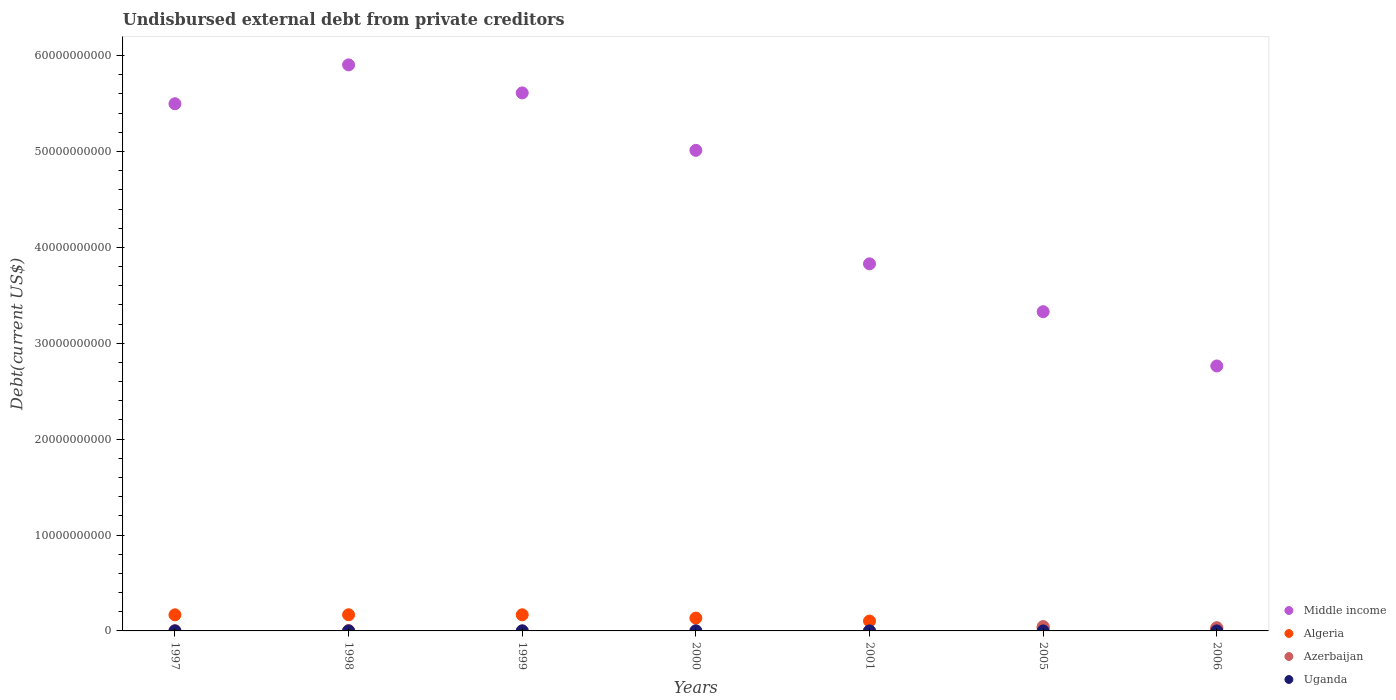How many different coloured dotlines are there?
Make the answer very short. 4. What is the total debt in Middle income in 2000?
Provide a short and direct response. 5.01e+1. Across all years, what is the maximum total debt in Algeria?
Keep it short and to the point. 1.69e+09. Across all years, what is the minimum total debt in Azerbaijan?
Your answer should be compact. 4.40e+04. What is the total total debt in Algeria in the graph?
Provide a short and direct response. 7.98e+09. What is the difference between the total debt in Middle income in 2005 and that in 2006?
Make the answer very short. 5.66e+09. What is the difference between the total debt in Azerbaijan in 2000 and the total debt in Algeria in 2005?
Ensure brevity in your answer.  -3.37e+08. What is the average total debt in Middle income per year?
Your response must be concise. 4.56e+1. In the year 1997, what is the difference between the total debt in Algeria and total debt in Middle income?
Offer a terse response. -5.33e+1. What is the ratio of the total debt in Uganda in 1998 to that in 2006?
Your answer should be compact. 6.67. Is the total debt in Middle income in 2000 less than that in 2006?
Provide a short and direct response. No. Is the difference between the total debt in Algeria in 1999 and 2000 greater than the difference between the total debt in Middle income in 1999 and 2000?
Your response must be concise. No. What is the difference between the highest and the second highest total debt in Algeria?
Offer a very short reply. 3.66e+06. What is the difference between the highest and the lowest total debt in Algeria?
Provide a short and direct response. 1.45e+09. Is it the case that in every year, the sum of the total debt in Uganda and total debt in Algeria  is greater than the total debt in Middle income?
Offer a terse response. No. Does the total debt in Algeria monotonically increase over the years?
Your answer should be very brief. No. Is the total debt in Uganda strictly greater than the total debt in Middle income over the years?
Provide a succinct answer. No. Is the total debt in Algeria strictly less than the total debt in Uganda over the years?
Offer a terse response. No. How many dotlines are there?
Offer a terse response. 4. How many years are there in the graph?
Provide a succinct answer. 7. What is the difference between two consecutive major ticks on the Y-axis?
Give a very brief answer. 1.00e+1. Does the graph contain grids?
Your response must be concise. No. Where does the legend appear in the graph?
Provide a short and direct response. Bottom right. What is the title of the graph?
Offer a very short reply. Undisbursed external debt from private creditors. Does "Senegal" appear as one of the legend labels in the graph?
Provide a succinct answer. No. What is the label or title of the Y-axis?
Offer a very short reply. Debt(current US$). What is the Debt(current US$) of Middle income in 1997?
Offer a very short reply. 5.50e+1. What is the Debt(current US$) in Algeria in 1997?
Make the answer very short. 1.68e+09. What is the Debt(current US$) of Azerbaijan in 1997?
Give a very brief answer. 2.42e+07. What is the Debt(current US$) in Uganda in 1997?
Give a very brief answer. 1.96e+05. What is the Debt(current US$) in Middle income in 1998?
Your answer should be compact. 5.90e+1. What is the Debt(current US$) of Algeria in 1998?
Provide a succinct answer. 1.69e+09. What is the Debt(current US$) in Azerbaijan in 1998?
Your answer should be very brief. 3.81e+07. What is the Debt(current US$) of Middle income in 1999?
Your answer should be very brief. 5.61e+1. What is the Debt(current US$) of Algeria in 1999?
Ensure brevity in your answer.  1.68e+09. What is the Debt(current US$) of Azerbaijan in 1999?
Offer a very short reply. 3.53e+06. What is the Debt(current US$) of Uganda in 1999?
Give a very brief answer. 1.76e+06. What is the Debt(current US$) in Middle income in 2000?
Provide a short and direct response. 5.01e+1. What is the Debt(current US$) in Algeria in 2000?
Your answer should be compact. 1.34e+09. What is the Debt(current US$) in Azerbaijan in 2000?
Ensure brevity in your answer.  5.81e+05. What is the Debt(current US$) in Uganda in 2000?
Your response must be concise. 4.61e+06. What is the Debt(current US$) of Middle income in 2001?
Your response must be concise. 3.83e+1. What is the Debt(current US$) of Algeria in 2001?
Give a very brief answer. 1.03e+09. What is the Debt(current US$) of Azerbaijan in 2001?
Make the answer very short. 4.40e+04. What is the Debt(current US$) of Uganda in 2001?
Your answer should be compact. 3.35e+05. What is the Debt(current US$) of Middle income in 2005?
Your response must be concise. 3.33e+1. What is the Debt(current US$) in Algeria in 2005?
Your answer should be very brief. 3.37e+08. What is the Debt(current US$) of Azerbaijan in 2005?
Ensure brevity in your answer.  4.53e+08. What is the Debt(current US$) of Uganda in 2005?
Offer a very short reply. 2.10e+04. What is the Debt(current US$) of Middle income in 2006?
Your answer should be compact. 2.76e+1. What is the Debt(current US$) in Algeria in 2006?
Offer a very short reply. 2.33e+08. What is the Debt(current US$) in Azerbaijan in 2006?
Keep it short and to the point. 3.36e+08. What is the Debt(current US$) of Uganda in 2006?
Offer a terse response. 2.40e+04. Across all years, what is the maximum Debt(current US$) of Middle income?
Offer a very short reply. 5.90e+1. Across all years, what is the maximum Debt(current US$) in Algeria?
Give a very brief answer. 1.69e+09. Across all years, what is the maximum Debt(current US$) of Azerbaijan?
Give a very brief answer. 4.53e+08. Across all years, what is the maximum Debt(current US$) in Uganda?
Provide a short and direct response. 4.61e+06. Across all years, what is the minimum Debt(current US$) in Middle income?
Keep it short and to the point. 2.76e+1. Across all years, what is the minimum Debt(current US$) in Algeria?
Make the answer very short. 2.33e+08. Across all years, what is the minimum Debt(current US$) of Azerbaijan?
Provide a short and direct response. 4.40e+04. Across all years, what is the minimum Debt(current US$) of Uganda?
Offer a very short reply. 2.10e+04. What is the total Debt(current US$) of Middle income in the graph?
Offer a terse response. 3.19e+11. What is the total Debt(current US$) of Algeria in the graph?
Your answer should be very brief. 7.98e+09. What is the total Debt(current US$) in Azerbaijan in the graph?
Your answer should be compact. 8.55e+08. What is the total Debt(current US$) in Uganda in the graph?
Your answer should be very brief. 7.11e+06. What is the difference between the Debt(current US$) in Middle income in 1997 and that in 1998?
Provide a short and direct response. -4.05e+09. What is the difference between the Debt(current US$) of Algeria in 1997 and that in 1998?
Offer a very short reply. -7.31e+06. What is the difference between the Debt(current US$) in Azerbaijan in 1997 and that in 1998?
Your response must be concise. -1.40e+07. What is the difference between the Debt(current US$) of Uganda in 1997 and that in 1998?
Ensure brevity in your answer.  3.60e+04. What is the difference between the Debt(current US$) in Middle income in 1997 and that in 1999?
Your response must be concise. -1.13e+09. What is the difference between the Debt(current US$) in Algeria in 1997 and that in 1999?
Provide a short and direct response. -3.65e+06. What is the difference between the Debt(current US$) in Azerbaijan in 1997 and that in 1999?
Give a very brief answer. 2.06e+07. What is the difference between the Debt(current US$) of Uganda in 1997 and that in 1999?
Give a very brief answer. -1.57e+06. What is the difference between the Debt(current US$) in Middle income in 1997 and that in 2000?
Your answer should be very brief. 4.86e+09. What is the difference between the Debt(current US$) of Algeria in 1997 and that in 2000?
Offer a very short reply. 3.40e+08. What is the difference between the Debt(current US$) of Azerbaijan in 1997 and that in 2000?
Give a very brief answer. 2.36e+07. What is the difference between the Debt(current US$) in Uganda in 1997 and that in 2000?
Make the answer very short. -4.42e+06. What is the difference between the Debt(current US$) in Middle income in 1997 and that in 2001?
Give a very brief answer. 1.67e+1. What is the difference between the Debt(current US$) of Algeria in 1997 and that in 2001?
Your answer should be compact. 6.52e+08. What is the difference between the Debt(current US$) of Azerbaijan in 1997 and that in 2001?
Your answer should be compact. 2.41e+07. What is the difference between the Debt(current US$) in Uganda in 1997 and that in 2001?
Your answer should be very brief. -1.39e+05. What is the difference between the Debt(current US$) in Middle income in 1997 and that in 2005?
Your answer should be compact. 2.17e+1. What is the difference between the Debt(current US$) in Algeria in 1997 and that in 2005?
Give a very brief answer. 1.34e+09. What is the difference between the Debt(current US$) of Azerbaijan in 1997 and that in 2005?
Your response must be concise. -4.29e+08. What is the difference between the Debt(current US$) of Uganda in 1997 and that in 2005?
Keep it short and to the point. 1.75e+05. What is the difference between the Debt(current US$) in Middle income in 1997 and that in 2006?
Your answer should be very brief. 2.73e+1. What is the difference between the Debt(current US$) in Algeria in 1997 and that in 2006?
Make the answer very short. 1.45e+09. What is the difference between the Debt(current US$) of Azerbaijan in 1997 and that in 2006?
Offer a terse response. -3.12e+08. What is the difference between the Debt(current US$) in Uganda in 1997 and that in 2006?
Make the answer very short. 1.72e+05. What is the difference between the Debt(current US$) of Middle income in 1998 and that in 1999?
Your answer should be compact. 2.92e+09. What is the difference between the Debt(current US$) in Algeria in 1998 and that in 1999?
Your answer should be compact. 3.66e+06. What is the difference between the Debt(current US$) in Azerbaijan in 1998 and that in 1999?
Your response must be concise. 3.46e+07. What is the difference between the Debt(current US$) of Uganda in 1998 and that in 1999?
Offer a very short reply. -1.60e+06. What is the difference between the Debt(current US$) of Middle income in 1998 and that in 2000?
Give a very brief answer. 8.91e+09. What is the difference between the Debt(current US$) in Algeria in 1998 and that in 2000?
Keep it short and to the point. 3.47e+08. What is the difference between the Debt(current US$) in Azerbaijan in 1998 and that in 2000?
Offer a terse response. 3.76e+07. What is the difference between the Debt(current US$) in Uganda in 1998 and that in 2000?
Your response must be concise. -4.45e+06. What is the difference between the Debt(current US$) of Middle income in 1998 and that in 2001?
Keep it short and to the point. 2.07e+1. What is the difference between the Debt(current US$) in Algeria in 1998 and that in 2001?
Keep it short and to the point. 6.59e+08. What is the difference between the Debt(current US$) of Azerbaijan in 1998 and that in 2001?
Your response must be concise. 3.81e+07. What is the difference between the Debt(current US$) of Uganda in 1998 and that in 2001?
Your answer should be compact. -1.75e+05. What is the difference between the Debt(current US$) of Middle income in 1998 and that in 2005?
Your answer should be very brief. 2.57e+1. What is the difference between the Debt(current US$) in Algeria in 1998 and that in 2005?
Your answer should be compact. 1.35e+09. What is the difference between the Debt(current US$) in Azerbaijan in 1998 and that in 2005?
Ensure brevity in your answer.  -4.15e+08. What is the difference between the Debt(current US$) of Uganda in 1998 and that in 2005?
Offer a very short reply. 1.39e+05. What is the difference between the Debt(current US$) in Middle income in 1998 and that in 2006?
Make the answer very short. 3.14e+1. What is the difference between the Debt(current US$) in Algeria in 1998 and that in 2006?
Make the answer very short. 1.45e+09. What is the difference between the Debt(current US$) of Azerbaijan in 1998 and that in 2006?
Offer a very short reply. -2.98e+08. What is the difference between the Debt(current US$) of Uganda in 1998 and that in 2006?
Offer a very short reply. 1.36e+05. What is the difference between the Debt(current US$) in Middle income in 1999 and that in 2000?
Provide a short and direct response. 5.99e+09. What is the difference between the Debt(current US$) of Algeria in 1999 and that in 2000?
Make the answer very short. 3.43e+08. What is the difference between the Debt(current US$) in Azerbaijan in 1999 and that in 2000?
Your answer should be very brief. 2.95e+06. What is the difference between the Debt(current US$) of Uganda in 1999 and that in 2000?
Give a very brief answer. -2.85e+06. What is the difference between the Debt(current US$) of Middle income in 1999 and that in 2001?
Keep it short and to the point. 1.78e+1. What is the difference between the Debt(current US$) of Algeria in 1999 and that in 2001?
Make the answer very short. 6.55e+08. What is the difference between the Debt(current US$) in Azerbaijan in 1999 and that in 2001?
Provide a succinct answer. 3.49e+06. What is the difference between the Debt(current US$) in Uganda in 1999 and that in 2001?
Provide a succinct answer. 1.43e+06. What is the difference between the Debt(current US$) in Middle income in 1999 and that in 2005?
Offer a terse response. 2.28e+1. What is the difference between the Debt(current US$) in Algeria in 1999 and that in 2005?
Ensure brevity in your answer.  1.34e+09. What is the difference between the Debt(current US$) of Azerbaijan in 1999 and that in 2005?
Your answer should be compact. -4.49e+08. What is the difference between the Debt(current US$) in Uganda in 1999 and that in 2005?
Offer a terse response. 1.74e+06. What is the difference between the Debt(current US$) in Middle income in 1999 and that in 2006?
Ensure brevity in your answer.  2.85e+1. What is the difference between the Debt(current US$) of Algeria in 1999 and that in 2006?
Provide a short and direct response. 1.45e+09. What is the difference between the Debt(current US$) of Azerbaijan in 1999 and that in 2006?
Provide a short and direct response. -3.33e+08. What is the difference between the Debt(current US$) of Uganda in 1999 and that in 2006?
Ensure brevity in your answer.  1.74e+06. What is the difference between the Debt(current US$) in Middle income in 2000 and that in 2001?
Ensure brevity in your answer.  1.18e+1. What is the difference between the Debt(current US$) of Algeria in 2000 and that in 2001?
Your answer should be very brief. 3.12e+08. What is the difference between the Debt(current US$) in Azerbaijan in 2000 and that in 2001?
Offer a terse response. 5.37e+05. What is the difference between the Debt(current US$) of Uganda in 2000 and that in 2001?
Provide a succinct answer. 4.28e+06. What is the difference between the Debt(current US$) of Middle income in 2000 and that in 2005?
Provide a succinct answer. 1.68e+1. What is the difference between the Debt(current US$) in Algeria in 2000 and that in 2005?
Provide a short and direct response. 1.00e+09. What is the difference between the Debt(current US$) in Azerbaijan in 2000 and that in 2005?
Provide a succinct answer. -4.52e+08. What is the difference between the Debt(current US$) in Uganda in 2000 and that in 2005?
Keep it short and to the point. 4.59e+06. What is the difference between the Debt(current US$) of Middle income in 2000 and that in 2006?
Keep it short and to the point. 2.25e+1. What is the difference between the Debt(current US$) in Algeria in 2000 and that in 2006?
Ensure brevity in your answer.  1.11e+09. What is the difference between the Debt(current US$) of Azerbaijan in 2000 and that in 2006?
Your answer should be compact. -3.36e+08. What is the difference between the Debt(current US$) in Uganda in 2000 and that in 2006?
Your answer should be very brief. 4.59e+06. What is the difference between the Debt(current US$) of Middle income in 2001 and that in 2005?
Offer a very short reply. 4.99e+09. What is the difference between the Debt(current US$) of Algeria in 2001 and that in 2005?
Make the answer very short. 6.89e+08. What is the difference between the Debt(current US$) in Azerbaijan in 2001 and that in 2005?
Provide a succinct answer. -4.53e+08. What is the difference between the Debt(current US$) of Uganda in 2001 and that in 2005?
Your answer should be compact. 3.14e+05. What is the difference between the Debt(current US$) in Middle income in 2001 and that in 2006?
Offer a very short reply. 1.07e+1. What is the difference between the Debt(current US$) in Algeria in 2001 and that in 2006?
Give a very brief answer. 7.93e+08. What is the difference between the Debt(current US$) of Azerbaijan in 2001 and that in 2006?
Your answer should be compact. -3.36e+08. What is the difference between the Debt(current US$) in Uganda in 2001 and that in 2006?
Keep it short and to the point. 3.11e+05. What is the difference between the Debt(current US$) in Middle income in 2005 and that in 2006?
Give a very brief answer. 5.66e+09. What is the difference between the Debt(current US$) of Algeria in 2005 and that in 2006?
Make the answer very short. 1.04e+08. What is the difference between the Debt(current US$) of Azerbaijan in 2005 and that in 2006?
Ensure brevity in your answer.  1.17e+08. What is the difference between the Debt(current US$) in Uganda in 2005 and that in 2006?
Your answer should be compact. -3000. What is the difference between the Debt(current US$) of Middle income in 1997 and the Debt(current US$) of Algeria in 1998?
Make the answer very short. 5.33e+1. What is the difference between the Debt(current US$) of Middle income in 1997 and the Debt(current US$) of Azerbaijan in 1998?
Your answer should be compact. 5.49e+1. What is the difference between the Debt(current US$) of Middle income in 1997 and the Debt(current US$) of Uganda in 1998?
Offer a terse response. 5.50e+1. What is the difference between the Debt(current US$) of Algeria in 1997 and the Debt(current US$) of Azerbaijan in 1998?
Your response must be concise. 1.64e+09. What is the difference between the Debt(current US$) in Algeria in 1997 and the Debt(current US$) in Uganda in 1998?
Provide a short and direct response. 1.68e+09. What is the difference between the Debt(current US$) in Azerbaijan in 1997 and the Debt(current US$) in Uganda in 1998?
Keep it short and to the point. 2.40e+07. What is the difference between the Debt(current US$) in Middle income in 1997 and the Debt(current US$) in Algeria in 1999?
Offer a terse response. 5.33e+1. What is the difference between the Debt(current US$) of Middle income in 1997 and the Debt(current US$) of Azerbaijan in 1999?
Keep it short and to the point. 5.50e+1. What is the difference between the Debt(current US$) in Middle income in 1997 and the Debt(current US$) in Uganda in 1999?
Ensure brevity in your answer.  5.50e+1. What is the difference between the Debt(current US$) in Algeria in 1997 and the Debt(current US$) in Azerbaijan in 1999?
Your answer should be compact. 1.67e+09. What is the difference between the Debt(current US$) in Algeria in 1997 and the Debt(current US$) in Uganda in 1999?
Provide a short and direct response. 1.68e+09. What is the difference between the Debt(current US$) in Azerbaijan in 1997 and the Debt(current US$) in Uganda in 1999?
Your answer should be compact. 2.24e+07. What is the difference between the Debt(current US$) in Middle income in 1997 and the Debt(current US$) in Algeria in 2000?
Keep it short and to the point. 5.36e+1. What is the difference between the Debt(current US$) in Middle income in 1997 and the Debt(current US$) in Azerbaijan in 2000?
Your answer should be compact. 5.50e+1. What is the difference between the Debt(current US$) in Middle income in 1997 and the Debt(current US$) in Uganda in 2000?
Your answer should be compact. 5.50e+1. What is the difference between the Debt(current US$) in Algeria in 1997 and the Debt(current US$) in Azerbaijan in 2000?
Your answer should be very brief. 1.68e+09. What is the difference between the Debt(current US$) in Algeria in 1997 and the Debt(current US$) in Uganda in 2000?
Offer a terse response. 1.67e+09. What is the difference between the Debt(current US$) of Azerbaijan in 1997 and the Debt(current US$) of Uganda in 2000?
Your answer should be compact. 1.96e+07. What is the difference between the Debt(current US$) in Middle income in 1997 and the Debt(current US$) in Algeria in 2001?
Provide a short and direct response. 5.40e+1. What is the difference between the Debt(current US$) of Middle income in 1997 and the Debt(current US$) of Azerbaijan in 2001?
Ensure brevity in your answer.  5.50e+1. What is the difference between the Debt(current US$) of Middle income in 1997 and the Debt(current US$) of Uganda in 2001?
Offer a terse response. 5.50e+1. What is the difference between the Debt(current US$) in Algeria in 1997 and the Debt(current US$) in Azerbaijan in 2001?
Make the answer very short. 1.68e+09. What is the difference between the Debt(current US$) in Algeria in 1997 and the Debt(current US$) in Uganda in 2001?
Your answer should be compact. 1.68e+09. What is the difference between the Debt(current US$) in Azerbaijan in 1997 and the Debt(current US$) in Uganda in 2001?
Your answer should be very brief. 2.38e+07. What is the difference between the Debt(current US$) in Middle income in 1997 and the Debt(current US$) in Algeria in 2005?
Your answer should be compact. 5.46e+1. What is the difference between the Debt(current US$) in Middle income in 1997 and the Debt(current US$) in Azerbaijan in 2005?
Provide a succinct answer. 5.45e+1. What is the difference between the Debt(current US$) of Middle income in 1997 and the Debt(current US$) of Uganda in 2005?
Provide a succinct answer. 5.50e+1. What is the difference between the Debt(current US$) in Algeria in 1997 and the Debt(current US$) in Azerbaijan in 2005?
Your response must be concise. 1.23e+09. What is the difference between the Debt(current US$) of Algeria in 1997 and the Debt(current US$) of Uganda in 2005?
Provide a short and direct response. 1.68e+09. What is the difference between the Debt(current US$) in Azerbaijan in 1997 and the Debt(current US$) in Uganda in 2005?
Provide a short and direct response. 2.42e+07. What is the difference between the Debt(current US$) in Middle income in 1997 and the Debt(current US$) in Algeria in 2006?
Ensure brevity in your answer.  5.47e+1. What is the difference between the Debt(current US$) in Middle income in 1997 and the Debt(current US$) in Azerbaijan in 2006?
Provide a succinct answer. 5.46e+1. What is the difference between the Debt(current US$) of Middle income in 1997 and the Debt(current US$) of Uganda in 2006?
Offer a very short reply. 5.50e+1. What is the difference between the Debt(current US$) in Algeria in 1997 and the Debt(current US$) in Azerbaijan in 2006?
Make the answer very short. 1.34e+09. What is the difference between the Debt(current US$) of Algeria in 1997 and the Debt(current US$) of Uganda in 2006?
Offer a terse response. 1.68e+09. What is the difference between the Debt(current US$) in Azerbaijan in 1997 and the Debt(current US$) in Uganda in 2006?
Make the answer very short. 2.41e+07. What is the difference between the Debt(current US$) of Middle income in 1998 and the Debt(current US$) of Algeria in 1999?
Your answer should be compact. 5.73e+1. What is the difference between the Debt(current US$) of Middle income in 1998 and the Debt(current US$) of Azerbaijan in 1999?
Offer a terse response. 5.90e+1. What is the difference between the Debt(current US$) in Middle income in 1998 and the Debt(current US$) in Uganda in 1999?
Offer a terse response. 5.90e+1. What is the difference between the Debt(current US$) in Algeria in 1998 and the Debt(current US$) in Azerbaijan in 1999?
Provide a succinct answer. 1.68e+09. What is the difference between the Debt(current US$) of Algeria in 1998 and the Debt(current US$) of Uganda in 1999?
Provide a short and direct response. 1.68e+09. What is the difference between the Debt(current US$) of Azerbaijan in 1998 and the Debt(current US$) of Uganda in 1999?
Keep it short and to the point. 3.64e+07. What is the difference between the Debt(current US$) of Middle income in 1998 and the Debt(current US$) of Algeria in 2000?
Ensure brevity in your answer.  5.77e+1. What is the difference between the Debt(current US$) in Middle income in 1998 and the Debt(current US$) in Azerbaijan in 2000?
Give a very brief answer. 5.90e+1. What is the difference between the Debt(current US$) of Middle income in 1998 and the Debt(current US$) of Uganda in 2000?
Make the answer very short. 5.90e+1. What is the difference between the Debt(current US$) of Algeria in 1998 and the Debt(current US$) of Azerbaijan in 2000?
Provide a succinct answer. 1.69e+09. What is the difference between the Debt(current US$) in Algeria in 1998 and the Debt(current US$) in Uganda in 2000?
Offer a very short reply. 1.68e+09. What is the difference between the Debt(current US$) of Azerbaijan in 1998 and the Debt(current US$) of Uganda in 2000?
Ensure brevity in your answer.  3.35e+07. What is the difference between the Debt(current US$) in Middle income in 1998 and the Debt(current US$) in Algeria in 2001?
Keep it short and to the point. 5.80e+1. What is the difference between the Debt(current US$) in Middle income in 1998 and the Debt(current US$) in Azerbaijan in 2001?
Ensure brevity in your answer.  5.90e+1. What is the difference between the Debt(current US$) in Middle income in 1998 and the Debt(current US$) in Uganda in 2001?
Ensure brevity in your answer.  5.90e+1. What is the difference between the Debt(current US$) in Algeria in 1998 and the Debt(current US$) in Azerbaijan in 2001?
Offer a terse response. 1.69e+09. What is the difference between the Debt(current US$) of Algeria in 1998 and the Debt(current US$) of Uganda in 2001?
Give a very brief answer. 1.69e+09. What is the difference between the Debt(current US$) of Azerbaijan in 1998 and the Debt(current US$) of Uganda in 2001?
Ensure brevity in your answer.  3.78e+07. What is the difference between the Debt(current US$) in Middle income in 1998 and the Debt(current US$) in Algeria in 2005?
Your response must be concise. 5.87e+1. What is the difference between the Debt(current US$) in Middle income in 1998 and the Debt(current US$) in Azerbaijan in 2005?
Offer a very short reply. 5.86e+1. What is the difference between the Debt(current US$) of Middle income in 1998 and the Debt(current US$) of Uganda in 2005?
Offer a very short reply. 5.90e+1. What is the difference between the Debt(current US$) of Algeria in 1998 and the Debt(current US$) of Azerbaijan in 2005?
Keep it short and to the point. 1.23e+09. What is the difference between the Debt(current US$) of Algeria in 1998 and the Debt(current US$) of Uganda in 2005?
Provide a short and direct response. 1.69e+09. What is the difference between the Debt(current US$) in Azerbaijan in 1998 and the Debt(current US$) in Uganda in 2005?
Your response must be concise. 3.81e+07. What is the difference between the Debt(current US$) in Middle income in 1998 and the Debt(current US$) in Algeria in 2006?
Keep it short and to the point. 5.88e+1. What is the difference between the Debt(current US$) in Middle income in 1998 and the Debt(current US$) in Azerbaijan in 2006?
Your answer should be compact. 5.87e+1. What is the difference between the Debt(current US$) of Middle income in 1998 and the Debt(current US$) of Uganda in 2006?
Ensure brevity in your answer.  5.90e+1. What is the difference between the Debt(current US$) in Algeria in 1998 and the Debt(current US$) in Azerbaijan in 2006?
Ensure brevity in your answer.  1.35e+09. What is the difference between the Debt(current US$) of Algeria in 1998 and the Debt(current US$) of Uganda in 2006?
Your answer should be compact. 1.69e+09. What is the difference between the Debt(current US$) in Azerbaijan in 1998 and the Debt(current US$) in Uganda in 2006?
Ensure brevity in your answer.  3.81e+07. What is the difference between the Debt(current US$) of Middle income in 1999 and the Debt(current US$) of Algeria in 2000?
Offer a terse response. 5.48e+1. What is the difference between the Debt(current US$) in Middle income in 1999 and the Debt(current US$) in Azerbaijan in 2000?
Provide a succinct answer. 5.61e+1. What is the difference between the Debt(current US$) in Middle income in 1999 and the Debt(current US$) in Uganda in 2000?
Keep it short and to the point. 5.61e+1. What is the difference between the Debt(current US$) of Algeria in 1999 and the Debt(current US$) of Azerbaijan in 2000?
Offer a terse response. 1.68e+09. What is the difference between the Debt(current US$) in Algeria in 1999 and the Debt(current US$) in Uganda in 2000?
Keep it short and to the point. 1.68e+09. What is the difference between the Debt(current US$) of Azerbaijan in 1999 and the Debt(current US$) of Uganda in 2000?
Provide a succinct answer. -1.08e+06. What is the difference between the Debt(current US$) of Middle income in 1999 and the Debt(current US$) of Algeria in 2001?
Ensure brevity in your answer.  5.51e+1. What is the difference between the Debt(current US$) in Middle income in 1999 and the Debt(current US$) in Azerbaijan in 2001?
Provide a succinct answer. 5.61e+1. What is the difference between the Debt(current US$) in Middle income in 1999 and the Debt(current US$) in Uganda in 2001?
Offer a very short reply. 5.61e+1. What is the difference between the Debt(current US$) in Algeria in 1999 and the Debt(current US$) in Azerbaijan in 2001?
Ensure brevity in your answer.  1.68e+09. What is the difference between the Debt(current US$) of Algeria in 1999 and the Debt(current US$) of Uganda in 2001?
Make the answer very short. 1.68e+09. What is the difference between the Debt(current US$) of Azerbaijan in 1999 and the Debt(current US$) of Uganda in 2001?
Give a very brief answer. 3.20e+06. What is the difference between the Debt(current US$) of Middle income in 1999 and the Debt(current US$) of Algeria in 2005?
Your response must be concise. 5.58e+1. What is the difference between the Debt(current US$) in Middle income in 1999 and the Debt(current US$) in Azerbaijan in 2005?
Keep it short and to the point. 5.57e+1. What is the difference between the Debt(current US$) in Middle income in 1999 and the Debt(current US$) in Uganda in 2005?
Keep it short and to the point. 5.61e+1. What is the difference between the Debt(current US$) in Algeria in 1999 and the Debt(current US$) in Azerbaijan in 2005?
Give a very brief answer. 1.23e+09. What is the difference between the Debt(current US$) of Algeria in 1999 and the Debt(current US$) of Uganda in 2005?
Your response must be concise. 1.68e+09. What is the difference between the Debt(current US$) of Azerbaijan in 1999 and the Debt(current US$) of Uganda in 2005?
Provide a short and direct response. 3.51e+06. What is the difference between the Debt(current US$) of Middle income in 1999 and the Debt(current US$) of Algeria in 2006?
Your answer should be very brief. 5.59e+1. What is the difference between the Debt(current US$) in Middle income in 1999 and the Debt(current US$) in Azerbaijan in 2006?
Offer a very short reply. 5.58e+1. What is the difference between the Debt(current US$) of Middle income in 1999 and the Debt(current US$) of Uganda in 2006?
Your answer should be very brief. 5.61e+1. What is the difference between the Debt(current US$) of Algeria in 1999 and the Debt(current US$) of Azerbaijan in 2006?
Your response must be concise. 1.35e+09. What is the difference between the Debt(current US$) in Algeria in 1999 and the Debt(current US$) in Uganda in 2006?
Your answer should be very brief. 1.68e+09. What is the difference between the Debt(current US$) of Azerbaijan in 1999 and the Debt(current US$) of Uganda in 2006?
Ensure brevity in your answer.  3.51e+06. What is the difference between the Debt(current US$) in Middle income in 2000 and the Debt(current US$) in Algeria in 2001?
Offer a terse response. 4.91e+1. What is the difference between the Debt(current US$) in Middle income in 2000 and the Debt(current US$) in Azerbaijan in 2001?
Your response must be concise. 5.01e+1. What is the difference between the Debt(current US$) of Middle income in 2000 and the Debt(current US$) of Uganda in 2001?
Keep it short and to the point. 5.01e+1. What is the difference between the Debt(current US$) in Algeria in 2000 and the Debt(current US$) in Azerbaijan in 2001?
Provide a succinct answer. 1.34e+09. What is the difference between the Debt(current US$) of Algeria in 2000 and the Debt(current US$) of Uganda in 2001?
Provide a succinct answer. 1.34e+09. What is the difference between the Debt(current US$) of Azerbaijan in 2000 and the Debt(current US$) of Uganda in 2001?
Give a very brief answer. 2.46e+05. What is the difference between the Debt(current US$) of Middle income in 2000 and the Debt(current US$) of Algeria in 2005?
Your answer should be compact. 4.98e+1. What is the difference between the Debt(current US$) in Middle income in 2000 and the Debt(current US$) in Azerbaijan in 2005?
Keep it short and to the point. 4.97e+1. What is the difference between the Debt(current US$) of Middle income in 2000 and the Debt(current US$) of Uganda in 2005?
Make the answer very short. 5.01e+1. What is the difference between the Debt(current US$) in Algeria in 2000 and the Debt(current US$) in Azerbaijan in 2005?
Keep it short and to the point. 8.86e+08. What is the difference between the Debt(current US$) of Algeria in 2000 and the Debt(current US$) of Uganda in 2005?
Provide a short and direct response. 1.34e+09. What is the difference between the Debt(current US$) of Azerbaijan in 2000 and the Debt(current US$) of Uganda in 2005?
Ensure brevity in your answer.  5.60e+05. What is the difference between the Debt(current US$) of Middle income in 2000 and the Debt(current US$) of Algeria in 2006?
Give a very brief answer. 4.99e+1. What is the difference between the Debt(current US$) in Middle income in 2000 and the Debt(current US$) in Azerbaijan in 2006?
Make the answer very short. 4.98e+1. What is the difference between the Debt(current US$) of Middle income in 2000 and the Debt(current US$) of Uganda in 2006?
Your answer should be very brief. 5.01e+1. What is the difference between the Debt(current US$) in Algeria in 2000 and the Debt(current US$) in Azerbaijan in 2006?
Make the answer very short. 1.00e+09. What is the difference between the Debt(current US$) in Algeria in 2000 and the Debt(current US$) in Uganda in 2006?
Your response must be concise. 1.34e+09. What is the difference between the Debt(current US$) in Azerbaijan in 2000 and the Debt(current US$) in Uganda in 2006?
Keep it short and to the point. 5.57e+05. What is the difference between the Debt(current US$) of Middle income in 2001 and the Debt(current US$) of Algeria in 2005?
Your answer should be compact. 3.79e+1. What is the difference between the Debt(current US$) in Middle income in 2001 and the Debt(current US$) in Azerbaijan in 2005?
Offer a very short reply. 3.78e+1. What is the difference between the Debt(current US$) in Middle income in 2001 and the Debt(current US$) in Uganda in 2005?
Make the answer very short. 3.83e+1. What is the difference between the Debt(current US$) of Algeria in 2001 and the Debt(current US$) of Azerbaijan in 2005?
Your answer should be compact. 5.74e+08. What is the difference between the Debt(current US$) of Algeria in 2001 and the Debt(current US$) of Uganda in 2005?
Give a very brief answer. 1.03e+09. What is the difference between the Debt(current US$) in Azerbaijan in 2001 and the Debt(current US$) in Uganda in 2005?
Your response must be concise. 2.30e+04. What is the difference between the Debt(current US$) in Middle income in 2001 and the Debt(current US$) in Algeria in 2006?
Keep it short and to the point. 3.80e+1. What is the difference between the Debt(current US$) in Middle income in 2001 and the Debt(current US$) in Azerbaijan in 2006?
Ensure brevity in your answer.  3.79e+1. What is the difference between the Debt(current US$) of Middle income in 2001 and the Debt(current US$) of Uganda in 2006?
Your answer should be very brief. 3.83e+1. What is the difference between the Debt(current US$) in Algeria in 2001 and the Debt(current US$) in Azerbaijan in 2006?
Keep it short and to the point. 6.91e+08. What is the difference between the Debt(current US$) in Algeria in 2001 and the Debt(current US$) in Uganda in 2006?
Ensure brevity in your answer.  1.03e+09. What is the difference between the Debt(current US$) in Middle income in 2005 and the Debt(current US$) in Algeria in 2006?
Offer a terse response. 3.31e+1. What is the difference between the Debt(current US$) in Middle income in 2005 and the Debt(current US$) in Azerbaijan in 2006?
Give a very brief answer. 3.30e+1. What is the difference between the Debt(current US$) of Middle income in 2005 and the Debt(current US$) of Uganda in 2006?
Provide a short and direct response. 3.33e+1. What is the difference between the Debt(current US$) of Algeria in 2005 and the Debt(current US$) of Azerbaijan in 2006?
Offer a very short reply. 1.30e+06. What is the difference between the Debt(current US$) of Algeria in 2005 and the Debt(current US$) of Uganda in 2006?
Offer a terse response. 3.37e+08. What is the difference between the Debt(current US$) in Azerbaijan in 2005 and the Debt(current US$) in Uganda in 2006?
Provide a short and direct response. 4.53e+08. What is the average Debt(current US$) in Middle income per year?
Offer a very short reply. 4.56e+1. What is the average Debt(current US$) in Algeria per year?
Provide a short and direct response. 1.14e+09. What is the average Debt(current US$) in Azerbaijan per year?
Provide a short and direct response. 1.22e+08. What is the average Debt(current US$) in Uganda per year?
Your response must be concise. 1.02e+06. In the year 1997, what is the difference between the Debt(current US$) in Middle income and Debt(current US$) in Algeria?
Give a very brief answer. 5.33e+1. In the year 1997, what is the difference between the Debt(current US$) of Middle income and Debt(current US$) of Azerbaijan?
Make the answer very short. 5.50e+1. In the year 1997, what is the difference between the Debt(current US$) of Middle income and Debt(current US$) of Uganda?
Provide a short and direct response. 5.50e+1. In the year 1997, what is the difference between the Debt(current US$) of Algeria and Debt(current US$) of Azerbaijan?
Your answer should be very brief. 1.65e+09. In the year 1997, what is the difference between the Debt(current US$) of Algeria and Debt(current US$) of Uganda?
Make the answer very short. 1.68e+09. In the year 1997, what is the difference between the Debt(current US$) in Azerbaijan and Debt(current US$) in Uganda?
Your answer should be very brief. 2.40e+07. In the year 1998, what is the difference between the Debt(current US$) of Middle income and Debt(current US$) of Algeria?
Give a very brief answer. 5.73e+1. In the year 1998, what is the difference between the Debt(current US$) of Middle income and Debt(current US$) of Azerbaijan?
Your response must be concise. 5.90e+1. In the year 1998, what is the difference between the Debt(current US$) in Middle income and Debt(current US$) in Uganda?
Ensure brevity in your answer.  5.90e+1. In the year 1998, what is the difference between the Debt(current US$) in Algeria and Debt(current US$) in Azerbaijan?
Offer a very short reply. 1.65e+09. In the year 1998, what is the difference between the Debt(current US$) of Algeria and Debt(current US$) of Uganda?
Provide a succinct answer. 1.69e+09. In the year 1998, what is the difference between the Debt(current US$) of Azerbaijan and Debt(current US$) of Uganda?
Your answer should be very brief. 3.80e+07. In the year 1999, what is the difference between the Debt(current US$) in Middle income and Debt(current US$) in Algeria?
Offer a terse response. 5.44e+1. In the year 1999, what is the difference between the Debt(current US$) in Middle income and Debt(current US$) in Azerbaijan?
Offer a very short reply. 5.61e+1. In the year 1999, what is the difference between the Debt(current US$) in Middle income and Debt(current US$) in Uganda?
Your answer should be very brief. 5.61e+1. In the year 1999, what is the difference between the Debt(current US$) of Algeria and Debt(current US$) of Azerbaijan?
Your answer should be compact. 1.68e+09. In the year 1999, what is the difference between the Debt(current US$) in Algeria and Debt(current US$) in Uganda?
Offer a very short reply. 1.68e+09. In the year 1999, what is the difference between the Debt(current US$) of Azerbaijan and Debt(current US$) of Uganda?
Your response must be concise. 1.77e+06. In the year 2000, what is the difference between the Debt(current US$) in Middle income and Debt(current US$) in Algeria?
Your answer should be compact. 4.88e+1. In the year 2000, what is the difference between the Debt(current US$) in Middle income and Debt(current US$) in Azerbaijan?
Offer a very short reply. 5.01e+1. In the year 2000, what is the difference between the Debt(current US$) in Middle income and Debt(current US$) in Uganda?
Offer a very short reply. 5.01e+1. In the year 2000, what is the difference between the Debt(current US$) in Algeria and Debt(current US$) in Azerbaijan?
Your answer should be compact. 1.34e+09. In the year 2000, what is the difference between the Debt(current US$) in Algeria and Debt(current US$) in Uganda?
Provide a succinct answer. 1.33e+09. In the year 2000, what is the difference between the Debt(current US$) in Azerbaijan and Debt(current US$) in Uganda?
Keep it short and to the point. -4.03e+06. In the year 2001, what is the difference between the Debt(current US$) in Middle income and Debt(current US$) in Algeria?
Provide a short and direct response. 3.73e+1. In the year 2001, what is the difference between the Debt(current US$) of Middle income and Debt(current US$) of Azerbaijan?
Your response must be concise. 3.83e+1. In the year 2001, what is the difference between the Debt(current US$) of Middle income and Debt(current US$) of Uganda?
Provide a succinct answer. 3.83e+1. In the year 2001, what is the difference between the Debt(current US$) in Algeria and Debt(current US$) in Azerbaijan?
Keep it short and to the point. 1.03e+09. In the year 2001, what is the difference between the Debt(current US$) in Algeria and Debt(current US$) in Uganda?
Offer a terse response. 1.03e+09. In the year 2001, what is the difference between the Debt(current US$) of Azerbaijan and Debt(current US$) of Uganda?
Your response must be concise. -2.91e+05. In the year 2005, what is the difference between the Debt(current US$) of Middle income and Debt(current US$) of Algeria?
Ensure brevity in your answer.  3.30e+1. In the year 2005, what is the difference between the Debt(current US$) of Middle income and Debt(current US$) of Azerbaijan?
Provide a short and direct response. 3.28e+1. In the year 2005, what is the difference between the Debt(current US$) of Middle income and Debt(current US$) of Uganda?
Provide a succinct answer. 3.33e+1. In the year 2005, what is the difference between the Debt(current US$) of Algeria and Debt(current US$) of Azerbaijan?
Your answer should be very brief. -1.15e+08. In the year 2005, what is the difference between the Debt(current US$) of Algeria and Debt(current US$) of Uganda?
Ensure brevity in your answer.  3.37e+08. In the year 2005, what is the difference between the Debt(current US$) of Azerbaijan and Debt(current US$) of Uganda?
Provide a succinct answer. 4.53e+08. In the year 2006, what is the difference between the Debt(current US$) of Middle income and Debt(current US$) of Algeria?
Your response must be concise. 2.74e+1. In the year 2006, what is the difference between the Debt(current US$) in Middle income and Debt(current US$) in Azerbaijan?
Keep it short and to the point. 2.73e+1. In the year 2006, what is the difference between the Debt(current US$) in Middle income and Debt(current US$) in Uganda?
Give a very brief answer. 2.76e+1. In the year 2006, what is the difference between the Debt(current US$) of Algeria and Debt(current US$) of Azerbaijan?
Make the answer very short. -1.03e+08. In the year 2006, what is the difference between the Debt(current US$) in Algeria and Debt(current US$) in Uganda?
Your answer should be compact. 2.33e+08. In the year 2006, what is the difference between the Debt(current US$) in Azerbaijan and Debt(current US$) in Uganda?
Offer a very short reply. 3.36e+08. What is the ratio of the Debt(current US$) in Middle income in 1997 to that in 1998?
Provide a short and direct response. 0.93. What is the ratio of the Debt(current US$) in Azerbaijan in 1997 to that in 1998?
Give a very brief answer. 0.63. What is the ratio of the Debt(current US$) in Uganda in 1997 to that in 1998?
Make the answer very short. 1.23. What is the ratio of the Debt(current US$) in Middle income in 1997 to that in 1999?
Offer a terse response. 0.98. What is the ratio of the Debt(current US$) of Azerbaijan in 1997 to that in 1999?
Your answer should be compact. 6.84. What is the ratio of the Debt(current US$) in Uganda in 1997 to that in 1999?
Offer a terse response. 0.11. What is the ratio of the Debt(current US$) in Middle income in 1997 to that in 2000?
Your response must be concise. 1.1. What is the ratio of the Debt(current US$) in Algeria in 1997 to that in 2000?
Give a very brief answer. 1.25. What is the ratio of the Debt(current US$) of Azerbaijan in 1997 to that in 2000?
Offer a terse response. 41.6. What is the ratio of the Debt(current US$) of Uganda in 1997 to that in 2000?
Your answer should be very brief. 0.04. What is the ratio of the Debt(current US$) in Middle income in 1997 to that in 2001?
Ensure brevity in your answer.  1.44. What is the ratio of the Debt(current US$) of Algeria in 1997 to that in 2001?
Ensure brevity in your answer.  1.63. What is the ratio of the Debt(current US$) in Azerbaijan in 1997 to that in 2001?
Ensure brevity in your answer.  549.34. What is the ratio of the Debt(current US$) of Uganda in 1997 to that in 2001?
Your response must be concise. 0.59. What is the ratio of the Debt(current US$) of Middle income in 1997 to that in 2005?
Keep it short and to the point. 1.65. What is the ratio of the Debt(current US$) of Algeria in 1997 to that in 2005?
Keep it short and to the point. 4.97. What is the ratio of the Debt(current US$) in Azerbaijan in 1997 to that in 2005?
Make the answer very short. 0.05. What is the ratio of the Debt(current US$) of Uganda in 1997 to that in 2005?
Your response must be concise. 9.33. What is the ratio of the Debt(current US$) in Middle income in 1997 to that in 2006?
Your response must be concise. 1.99. What is the ratio of the Debt(current US$) in Algeria in 1997 to that in 2006?
Offer a terse response. 7.19. What is the ratio of the Debt(current US$) in Azerbaijan in 1997 to that in 2006?
Your response must be concise. 0.07. What is the ratio of the Debt(current US$) of Uganda in 1997 to that in 2006?
Ensure brevity in your answer.  8.17. What is the ratio of the Debt(current US$) in Middle income in 1998 to that in 1999?
Your answer should be very brief. 1.05. What is the ratio of the Debt(current US$) of Algeria in 1998 to that in 1999?
Give a very brief answer. 1. What is the ratio of the Debt(current US$) in Azerbaijan in 1998 to that in 1999?
Provide a succinct answer. 10.8. What is the ratio of the Debt(current US$) of Uganda in 1998 to that in 1999?
Provide a short and direct response. 0.09. What is the ratio of the Debt(current US$) of Middle income in 1998 to that in 2000?
Make the answer very short. 1.18. What is the ratio of the Debt(current US$) in Algeria in 1998 to that in 2000?
Make the answer very short. 1.26. What is the ratio of the Debt(current US$) of Azerbaijan in 1998 to that in 2000?
Your answer should be compact. 65.65. What is the ratio of the Debt(current US$) in Uganda in 1998 to that in 2000?
Your response must be concise. 0.03. What is the ratio of the Debt(current US$) in Middle income in 1998 to that in 2001?
Your answer should be very brief. 1.54. What is the ratio of the Debt(current US$) of Algeria in 1998 to that in 2001?
Your answer should be compact. 1.64. What is the ratio of the Debt(current US$) of Azerbaijan in 1998 to that in 2001?
Provide a succinct answer. 866.86. What is the ratio of the Debt(current US$) of Uganda in 1998 to that in 2001?
Your answer should be very brief. 0.48. What is the ratio of the Debt(current US$) in Middle income in 1998 to that in 2005?
Provide a succinct answer. 1.77. What is the ratio of the Debt(current US$) in Algeria in 1998 to that in 2005?
Offer a very short reply. 5. What is the ratio of the Debt(current US$) in Azerbaijan in 1998 to that in 2005?
Ensure brevity in your answer.  0.08. What is the ratio of the Debt(current US$) in Uganda in 1998 to that in 2005?
Your answer should be compact. 7.62. What is the ratio of the Debt(current US$) in Middle income in 1998 to that in 2006?
Offer a very short reply. 2.14. What is the ratio of the Debt(current US$) of Algeria in 1998 to that in 2006?
Keep it short and to the point. 7.22. What is the ratio of the Debt(current US$) of Azerbaijan in 1998 to that in 2006?
Ensure brevity in your answer.  0.11. What is the ratio of the Debt(current US$) of Uganda in 1998 to that in 2006?
Your answer should be compact. 6.67. What is the ratio of the Debt(current US$) in Middle income in 1999 to that in 2000?
Give a very brief answer. 1.12. What is the ratio of the Debt(current US$) in Algeria in 1999 to that in 2000?
Offer a terse response. 1.26. What is the ratio of the Debt(current US$) in Azerbaijan in 1999 to that in 2000?
Your answer should be very brief. 6.08. What is the ratio of the Debt(current US$) of Uganda in 1999 to that in 2000?
Your response must be concise. 0.38. What is the ratio of the Debt(current US$) of Middle income in 1999 to that in 2001?
Offer a very short reply. 1.47. What is the ratio of the Debt(current US$) in Algeria in 1999 to that in 2001?
Give a very brief answer. 1.64. What is the ratio of the Debt(current US$) in Azerbaijan in 1999 to that in 2001?
Your answer should be compact. 80.27. What is the ratio of the Debt(current US$) in Uganda in 1999 to that in 2001?
Give a very brief answer. 5.27. What is the ratio of the Debt(current US$) in Middle income in 1999 to that in 2005?
Ensure brevity in your answer.  1.69. What is the ratio of the Debt(current US$) of Algeria in 1999 to that in 2005?
Keep it short and to the point. 4.98. What is the ratio of the Debt(current US$) of Azerbaijan in 1999 to that in 2005?
Ensure brevity in your answer.  0.01. What is the ratio of the Debt(current US$) of Middle income in 1999 to that in 2006?
Offer a terse response. 2.03. What is the ratio of the Debt(current US$) in Algeria in 1999 to that in 2006?
Offer a very short reply. 7.21. What is the ratio of the Debt(current US$) in Azerbaijan in 1999 to that in 2006?
Make the answer very short. 0.01. What is the ratio of the Debt(current US$) in Uganda in 1999 to that in 2006?
Your answer should be very brief. 73.5. What is the ratio of the Debt(current US$) of Middle income in 2000 to that in 2001?
Make the answer very short. 1.31. What is the ratio of the Debt(current US$) of Algeria in 2000 to that in 2001?
Provide a succinct answer. 1.3. What is the ratio of the Debt(current US$) of Azerbaijan in 2000 to that in 2001?
Make the answer very short. 13.2. What is the ratio of the Debt(current US$) in Uganda in 2000 to that in 2001?
Provide a short and direct response. 13.77. What is the ratio of the Debt(current US$) in Middle income in 2000 to that in 2005?
Give a very brief answer. 1.51. What is the ratio of the Debt(current US$) in Algeria in 2000 to that in 2005?
Ensure brevity in your answer.  3.97. What is the ratio of the Debt(current US$) in Azerbaijan in 2000 to that in 2005?
Ensure brevity in your answer.  0. What is the ratio of the Debt(current US$) in Uganda in 2000 to that in 2005?
Your answer should be very brief. 219.67. What is the ratio of the Debt(current US$) of Middle income in 2000 to that in 2006?
Offer a very short reply. 1.81. What is the ratio of the Debt(current US$) of Algeria in 2000 to that in 2006?
Provide a succinct answer. 5.73. What is the ratio of the Debt(current US$) of Azerbaijan in 2000 to that in 2006?
Ensure brevity in your answer.  0. What is the ratio of the Debt(current US$) of Uganda in 2000 to that in 2006?
Your answer should be very brief. 192.21. What is the ratio of the Debt(current US$) in Middle income in 2001 to that in 2005?
Make the answer very short. 1.15. What is the ratio of the Debt(current US$) in Algeria in 2001 to that in 2005?
Provide a short and direct response. 3.04. What is the ratio of the Debt(current US$) in Uganda in 2001 to that in 2005?
Your response must be concise. 15.95. What is the ratio of the Debt(current US$) in Middle income in 2001 to that in 2006?
Make the answer very short. 1.39. What is the ratio of the Debt(current US$) of Algeria in 2001 to that in 2006?
Provide a short and direct response. 4.4. What is the ratio of the Debt(current US$) in Uganda in 2001 to that in 2006?
Your answer should be compact. 13.96. What is the ratio of the Debt(current US$) in Middle income in 2005 to that in 2006?
Provide a short and direct response. 1.2. What is the ratio of the Debt(current US$) of Algeria in 2005 to that in 2006?
Your answer should be compact. 1.45. What is the ratio of the Debt(current US$) of Azerbaijan in 2005 to that in 2006?
Keep it short and to the point. 1.35. What is the difference between the highest and the second highest Debt(current US$) of Middle income?
Ensure brevity in your answer.  2.92e+09. What is the difference between the highest and the second highest Debt(current US$) in Algeria?
Give a very brief answer. 3.66e+06. What is the difference between the highest and the second highest Debt(current US$) in Azerbaijan?
Provide a short and direct response. 1.17e+08. What is the difference between the highest and the second highest Debt(current US$) of Uganda?
Give a very brief answer. 2.85e+06. What is the difference between the highest and the lowest Debt(current US$) of Middle income?
Offer a terse response. 3.14e+1. What is the difference between the highest and the lowest Debt(current US$) in Algeria?
Keep it short and to the point. 1.45e+09. What is the difference between the highest and the lowest Debt(current US$) in Azerbaijan?
Provide a succinct answer. 4.53e+08. What is the difference between the highest and the lowest Debt(current US$) in Uganda?
Make the answer very short. 4.59e+06. 